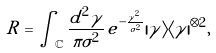Convert formula to latex. <formula><loc_0><loc_0><loc_500><loc_500>R = \int _ { \mathbb { C } } \frac { d ^ { 2 } \gamma } { \pi \sigma ^ { 2 } } \, e ^ { - \frac { | \gamma | ^ { 2 } } { \sigma ^ { 2 } } } | \gamma \rangle \langle \gamma | ^ { \otimes 2 } ,</formula> 